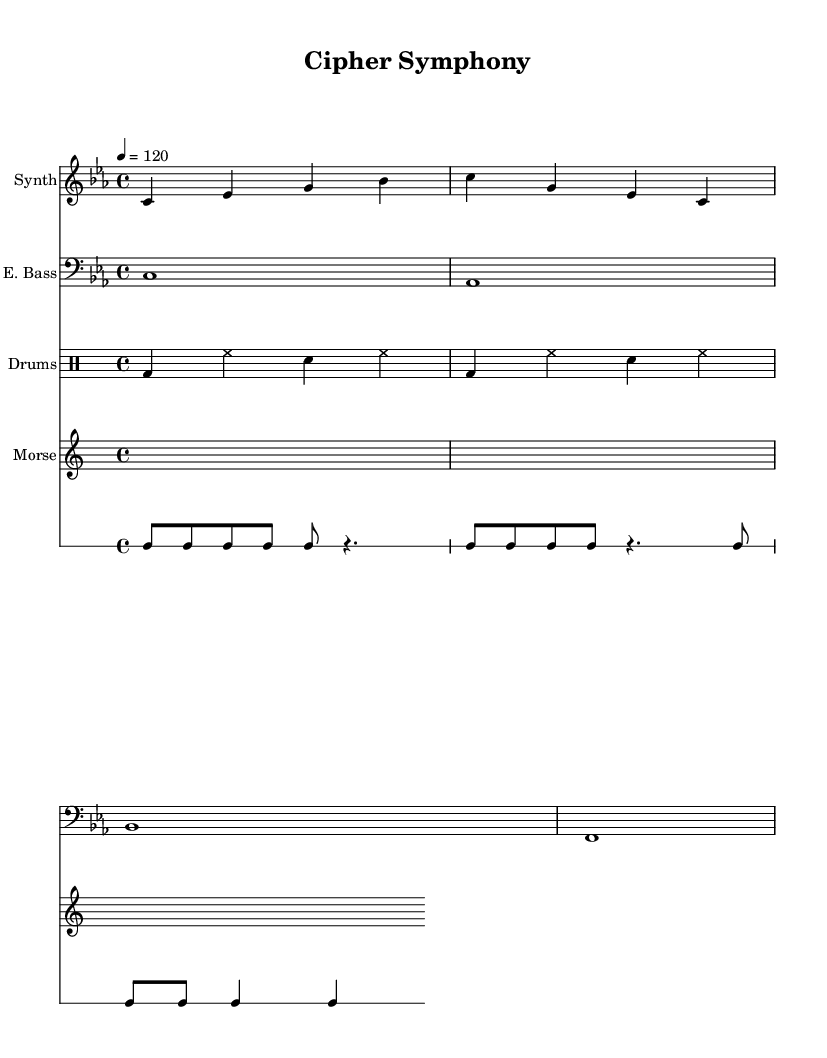What is the key signature of this music? The key signature is C minor, which has three flats: B flat, E flat, and A flat. This is indicated at the beginning of the score.
Answer: C minor What is the time signature of this music? The time signature is 4/4, which means there are four beats in each measure, and the quarter note receives one beat. This is displayed at the beginning of the score.
Answer: 4/4 What is the tempo marking for this piece? The tempo is marked as 120 beats per minute, indicated in the score after the time signature. This tempo gives a moderate pace to the music.
Answer: 120 How many measures are in the Synth part? The Synth part contains four measures, as evidenced by the groupings of bars in the staff. Each measure is separated by bar lines, showing a clear count of 1, 2, 3, and 4.
Answer: 4 What instrument is depicted in the bass clef? The instrument in the bass clef is the electric bass, as it is specified above the staff and chords are written in that clef. The bass part has a deeper sound, typical for the instrument.
Answer: E. Bass How many beats does the first measure of the drum machine have? The first measure of the drum machine consists of four beats, represented as one whole note (bd) and three additional beats (hh and sn), totaling four sounds, which equals four beats.
Answer: 4 What rhythmic pattern does the Morse code follow? The Morse code has a rhythmic pattern of four eighth notes followed by a quarter note rest (c8 c8 c8 c8 r4.), indicating a repeated sequence in rhythm emphasizing a coded message.
Answer: Four eighth notes 